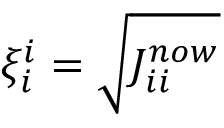Convert formula to latex. <formula><loc_0><loc_0><loc_500><loc_500>\xi _ { i } ^ { i } = \sqrt { J _ { i i } ^ { n o w } }</formula> 